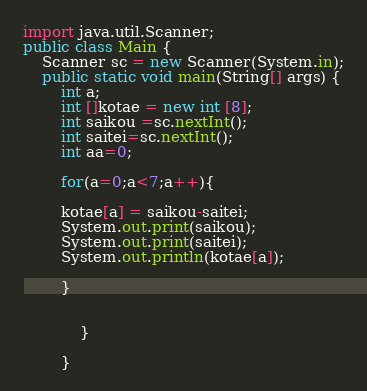Convert code to text. <code><loc_0><loc_0><loc_500><loc_500><_Java_>import java.util.Scanner;
public class Main {
	Scanner sc = new Scanner(System.in);
	public static void main(String[] args) {
		int a;
		int []kotae = new int [8];
		int saikou =sc.nextInt();
		int saitei=sc.nextInt();
		int aa=0;

		for(a=0;a<7;a++){
		
		kotae[a] = saikou-saitei;
		System.out.print(saikou);
		System.out.print(saitei);
		System.out.println(kotae[a]);
			
		}
			
				
	       	}

		}</code> 